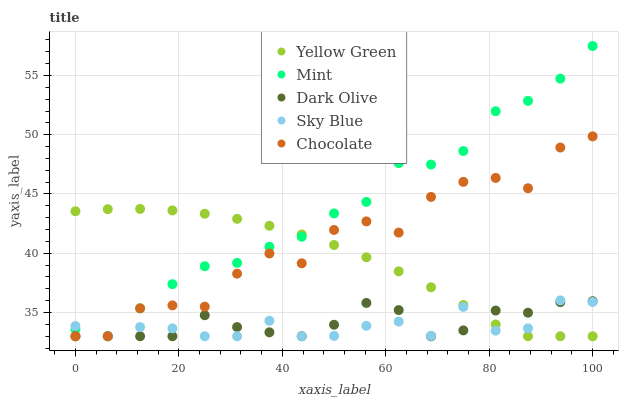Does Sky Blue have the minimum area under the curve?
Answer yes or no. Yes. Does Mint have the maximum area under the curve?
Answer yes or no. Yes. Does Dark Olive have the minimum area under the curve?
Answer yes or no. No. Does Dark Olive have the maximum area under the curve?
Answer yes or no. No. Is Yellow Green the smoothest?
Answer yes or no. Yes. Is Chocolate the roughest?
Answer yes or no. Yes. Is Dark Olive the smoothest?
Answer yes or no. No. Is Dark Olive the roughest?
Answer yes or no. No. Does Sky Blue have the lowest value?
Answer yes or no. Yes. Does Mint have the highest value?
Answer yes or no. Yes. Does Dark Olive have the highest value?
Answer yes or no. No. Does Mint intersect Chocolate?
Answer yes or no. Yes. Is Mint less than Chocolate?
Answer yes or no. No. Is Mint greater than Chocolate?
Answer yes or no. No. 